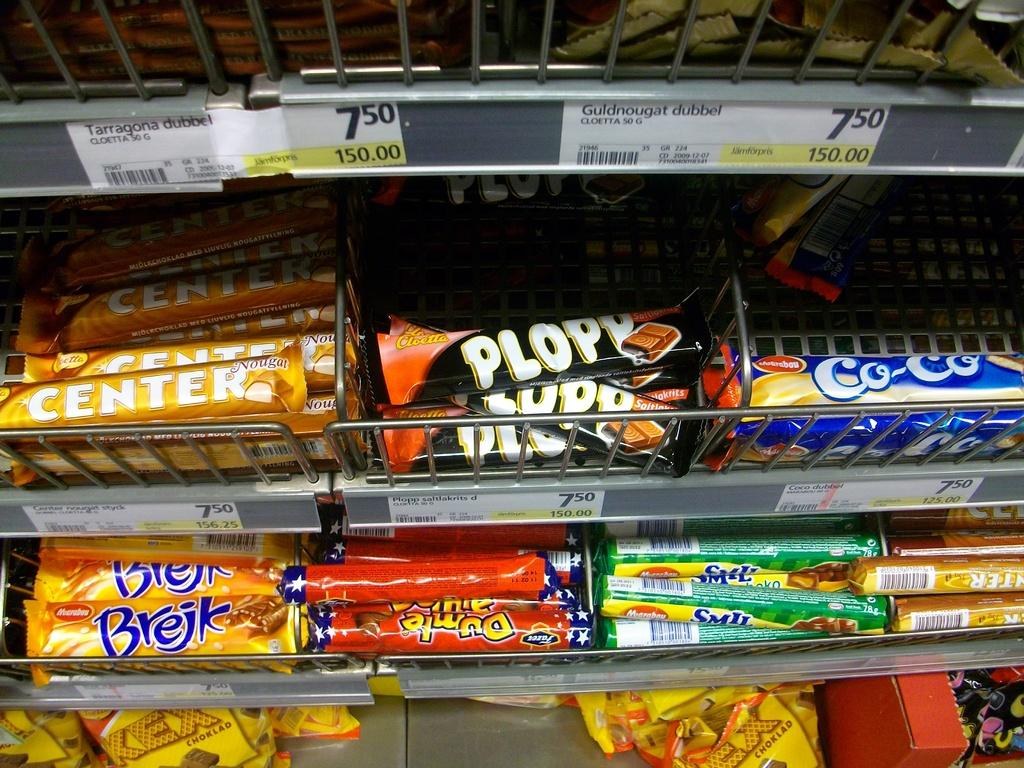<image>
Describe the image concisely. Several confectionaries are on display, including one called Brejk. 